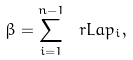<formula> <loc_0><loc_0><loc_500><loc_500>\beta = \sum _ { i = 1 } ^ { n - 1 } \ r L a p _ { i } ,</formula> 